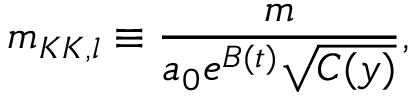Convert formula to latex. <formula><loc_0><loc_0><loc_500><loc_500>m _ { K K , l } \equiv \frac { m } { a _ { 0 } e ^ { B ( t ) } \sqrt { C ( y ) } } ,</formula> 